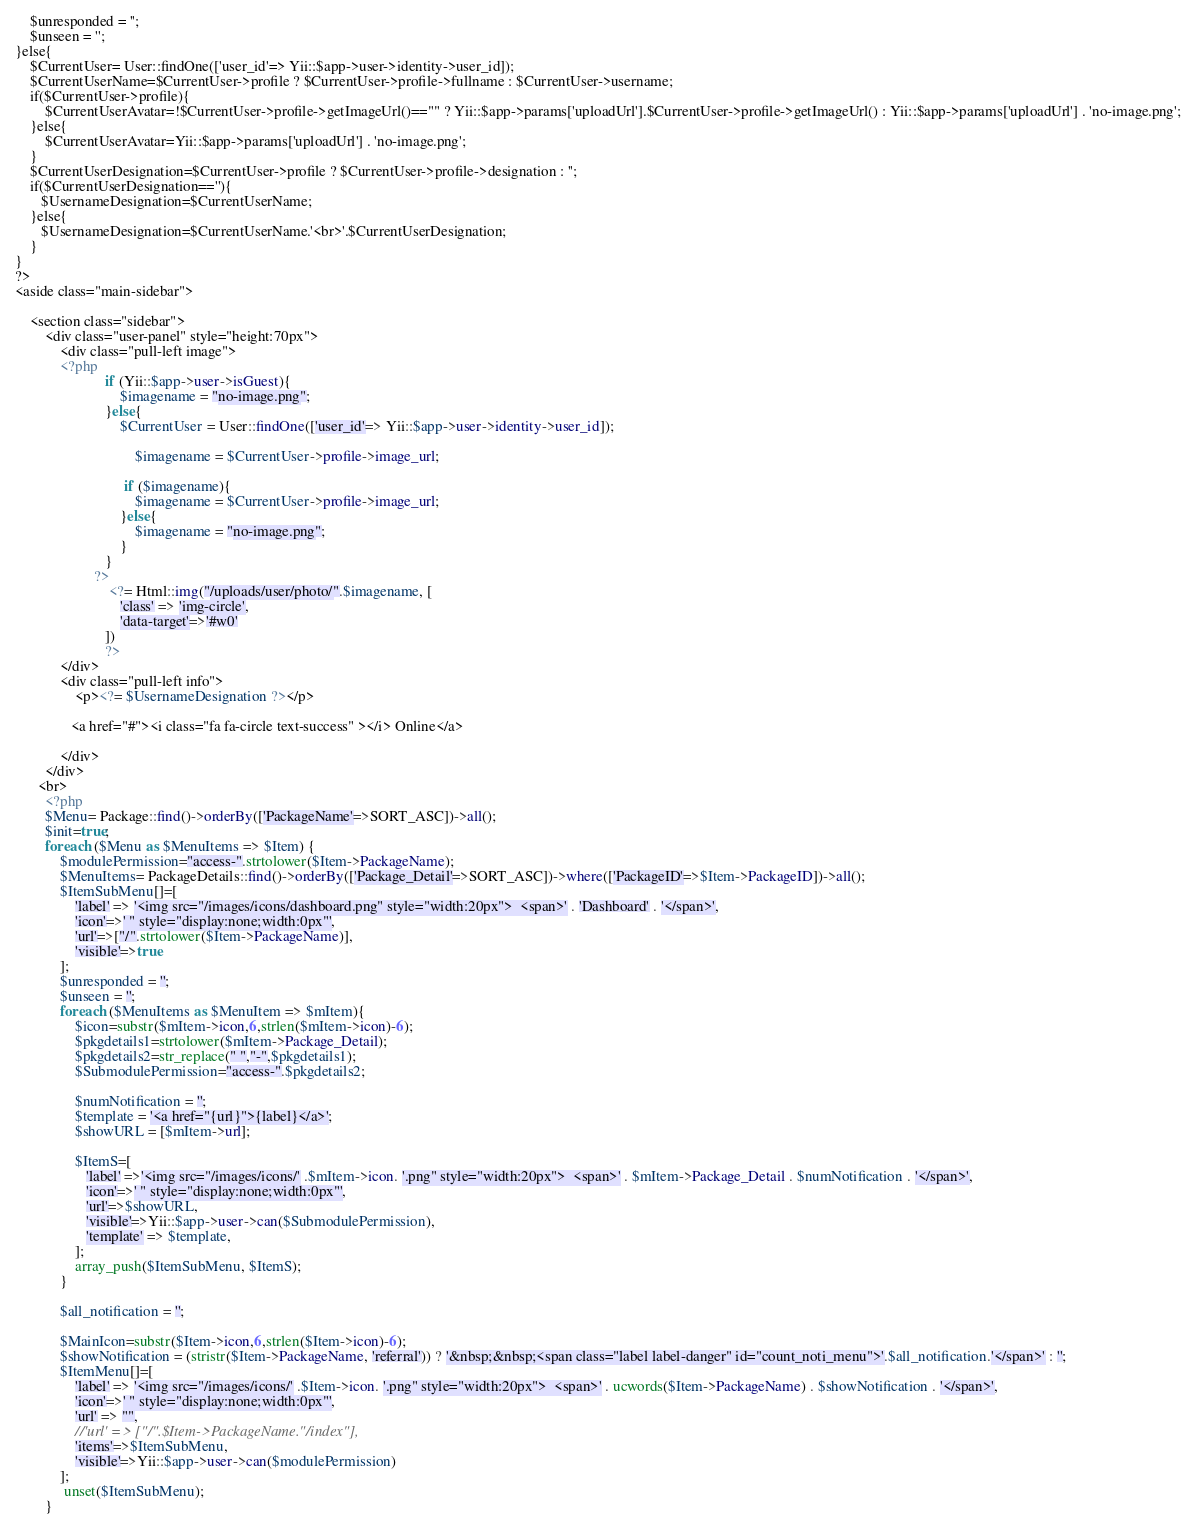Convert code to text. <code><loc_0><loc_0><loc_500><loc_500><_PHP_>	$unresponded = '';
	$unseen = '';
}else{
    $CurrentUser= User::findOne(['user_id'=> Yii::$app->user->identity->user_id]);
    $CurrentUserName=$CurrentUser->profile ? $CurrentUser->profile->fullname : $CurrentUser->username;
    if($CurrentUser->profile){
        $CurrentUserAvatar=!$CurrentUser->profile->getImageUrl()=="" ? Yii::$app->params['uploadUrl'].$CurrentUser->profile->getImageUrl() : Yii::$app->params['uploadUrl'] . 'no-image.png';
    }else{
        $CurrentUserAvatar=Yii::$app->params['uploadUrl'] . 'no-image.png';
    }
    $CurrentUserDesignation=$CurrentUser->profile ? $CurrentUser->profile->designation : '';
    if($CurrentUserDesignation==''){
       $UsernameDesignation=$CurrentUserName;
    }else{
       $UsernameDesignation=$CurrentUserName.'<br>'.$CurrentUserDesignation;
    }
}
?>
<aside class="main-sidebar">

    <section class="sidebar">       
        <div class="user-panel" style="height:70px">
            <div class="pull-left image">
            <?php 
                        if (Yii::$app->user->isGuest){
                            $imagename = "no-image.png";
                        }else{
                            $CurrentUser = User::findOne(['user_id'=> Yii::$app->user->identity->user_id]);
                        
                                $imagename = $CurrentUser->profile->image_url;
                           
                             if ($imagename){
                                $imagename = $CurrentUser->profile->image_url;
                            }else{
                                $imagename = "no-image.png";
                            }
                        }
                     ?>  
                         <?= Html::img("/uploads/user/photo/".$imagename, [ 
                            'class' => 'img-circle',     
                            'data-target'=>'#w0'
                        ]) 
                        ?>
            </div>
            <div class="pull-left info">
                <p><?= $UsernameDesignation ?></p>
              
               <a href="#"><i class="fa fa-circle text-success" ></i> Online</a>
                
            </div>
        </div>
      <br>
        <?php
        $Menu= Package::find()->orderBy(['PackageName'=>SORT_ASC])->all();
        $init=true;
        foreach ($Menu as $MenuItems => $Item) {
            $modulePermission="access-".strtolower($Item->PackageName);
            $MenuItems= PackageDetails::find()->orderBy(['Package_Detail'=>SORT_ASC])->where(['PackageID'=>$Item->PackageID])->all();
            $ItemSubMenu[]=[
                'label' => '<img src="/images/icons/dashboard.png" style="width:20px">  <span>' . 'Dashboard' . '</span>', 
                'icon'=>' " style="display:none;width:0px"',
                'url'=>["/".strtolower($Item->PackageName)],
                'visible'=>true
            ];
            $unresponded = '';
	        $unseen = '';
            foreach ($MenuItems as $MenuItem => $mItem){
                $icon=substr($mItem->icon,6,strlen($mItem->icon)-6);
                $pkgdetails1=strtolower($mItem->Package_Detail);
                $pkgdetails2=str_replace(" ","-",$pkgdetails1);
                $SubmodulePermission="access-".$pkgdetails2;

                $numNotification = '';
                $template = '<a href="{url}">{label}</a>';
                $showURL = [$mItem->url];
                
                $ItemS=[
                   'label' =>'<img src="/images/icons/' .$mItem->icon. '.png" style="width:20px">  <span>' . $mItem->Package_Detail . $numNotification . '</span>', 
                   'icon'=>' " style="display:none;width:0px"',
                   'url'=>$showURL,
                   'visible'=>Yii::$app->user->can($SubmodulePermission),
				   'template' => $template,
                ];
                array_push($ItemSubMenu, $ItemS);
            }
			
            $all_notification = '';

            $MainIcon=substr($Item->icon,6,strlen($Item->icon)-6);
			$showNotification = (stristr($Item->PackageName, 'referral')) ? '&nbsp;&nbsp;<span class="label label-danger" id="count_noti_menu">'.$all_notification.'</span>' : '';
            $ItemMenu[]=[
                'label' => '<img src="/images/icons/' .$Item->icon. '.png" style="width:20px">  <span>' . ucwords($Item->PackageName) . $showNotification . '</span>', 
                'icon'=>' " style="display:none;width:0px"',
                'url' => "",
                //'url' => ["/".$Item->PackageName."/index"],
                'items'=>$ItemSubMenu,
                'visible'=>Yii::$app->user->can($modulePermission)
            ]; 
             unset($ItemSubMenu);
        }</code> 